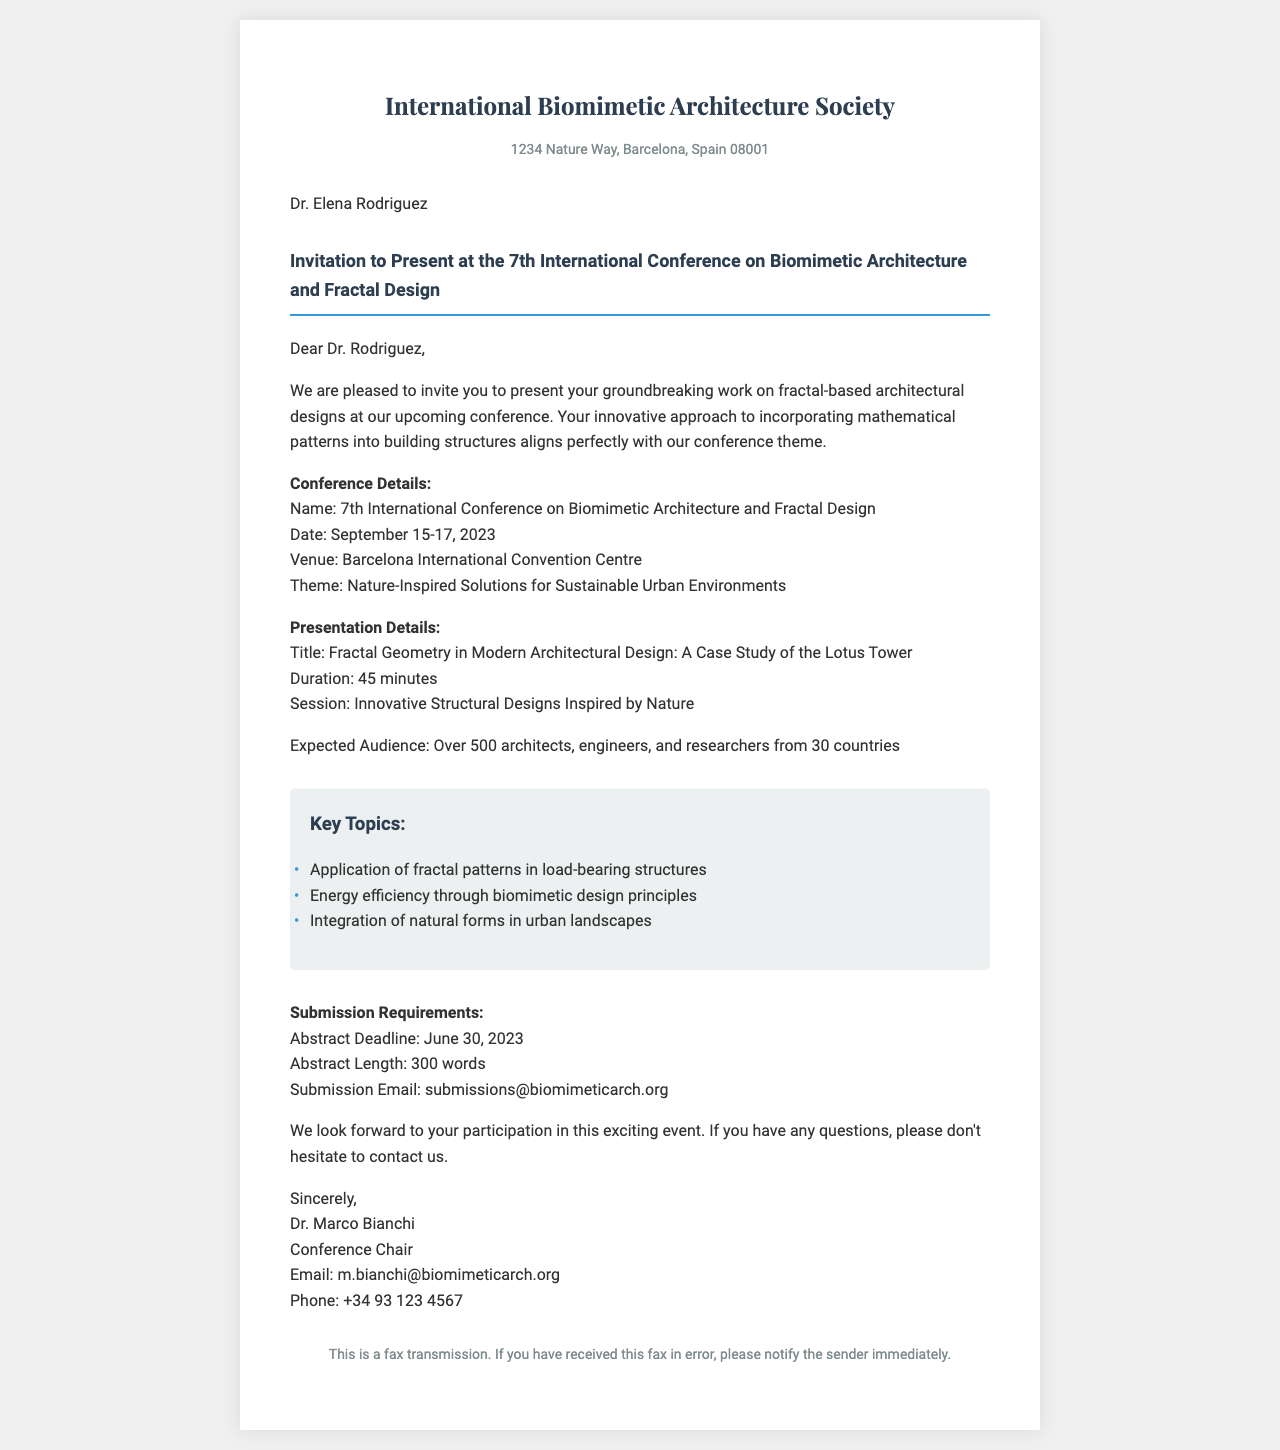what is the name of the conference? The document specifies the name of the conference is the 7th International Conference on Biomimetic Architecture and Fractal Design.
Answer: 7th International Conference on Biomimetic Architecture and Fractal Design what are the conference dates? The conference is scheduled for September 15-17, 2023.
Answer: September 15-17, 2023 who is the recipient of the fax? The recipient of the fax, as mentioned in the document, is Dr. Elena Rodriguez.
Answer: Dr. Elena Rodriguez what is the expected audience size? The document states that the expected audience is over 500 architects, engineers, and researchers.
Answer: Over 500 what is the abstract deadline? According to the document, the abstract deadline is June 30, 2023.
Answer: June 30, 2023 what key topic is related to natural forms? The document lists "Integration of natural forms in urban landscapes" as a key topic.
Answer: Integration of natural forms in urban landscapes how long is the presentation duration? The duration of the presentation as specified in the document is 45 minutes.
Answer: 45 minutes who is the conference chair? The document mentions that Dr. Marco Bianchi is the Conference Chair.
Answer: Dr. Marco Bianchi what is the submission email? The submission email provided in the document is submissions@biomimeticarch.org.
Answer: submissions@biomimeticarch.org 